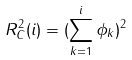<formula> <loc_0><loc_0><loc_500><loc_500>R ^ { 2 } _ { C } ( i ) = ( \sum _ { k = 1 } ^ { i } \phi _ { k } ) ^ { 2 }</formula> 